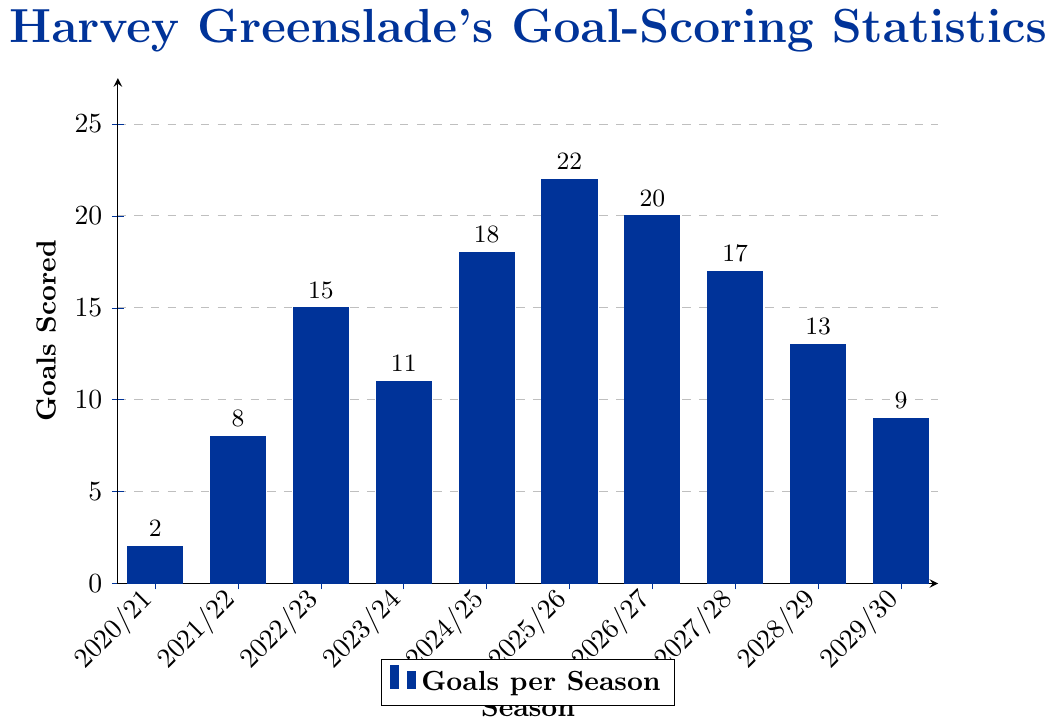What's the total number of goals scored by Harvey Greenslade over all seasons? Sum the goals across each season: 2 + 8 + 15 + 11 + 18 + 22 + 20 + 17 + 13 + 9 = 135
Answer: 135 In which season did Harvey Greenslade score the highest number of goals? Look for the tallest bar in the bar chart, which represents the highest number of goals scored in a season. It happens in the 2025/26 season with 22 goals.
Answer: 2025/26 How many goals did Harvey Greenslade score in the 2027/28 season and how does it compare to the 2024/25 season? In 2027/28, he scored 17 goals, and in 2024/25, he scored 18 goals. Therefore, he scored 1 goal less in 2027/28 than in 2024/25.
Answer: 1 goal less What's the sum of goals scored in the first and last seasons? For the 2020/21 season, he scored 2 goals. For the 2029/30 season, he scored 9 goals. Sum these up: 2 + 9 = 11
Answer: 11 Which seasons did Harvey Greenslade score more than 15 goals and list them? Identify seasons where the bar height is above 15 goals: 2022/23, 2024/25, 2025/26, 2026/27, and 2027/28 meet the criteria.
Answer: 2022/23, 2024/25, 2025/26, 2026/27 What's the average number of goals per season over these ten seasons? Sum all the goals and divide by the number of seasons: (2 + 8 + 15 + 11 + 18 + 22 + 20 + 17 + 13 + 9) / 10 = 135 / 10 = 13.5
Answer: 13.5 How does the number of goals in the 2026/27 season compare to the 2023/24 season? In 2026/27, he scored 20 goals and in 2023/24, he scored 11 goals. 20 - 11 = 9, so he scored 9 more goals in 2026/27 than in 2023/24.
Answer: 9 more goals What is the difference in goals scored between the much-better and the worst season? The highest season is 2025/26 with 22 goals, and the lowest is 2020/21 with 2 goals. Difference is 22 - 2 = 20
Answer: 20 In which season did the number of goals drop the most compared to the previous season? Calculate the drops between consecutive seasons: from 2025/26 to 2026/27, it's 2 goals less, which is the largest drop.
Answer: 2026/27 What is the median number of goals scored per season? Arrange the goals in order: 2, 8, 9, 11, 13, 15, 17, 18, 20, 22. The median value for 10 data points is the average of the 5th and 6th values, (13 + 15) / 2 = 14
Answer: 14 